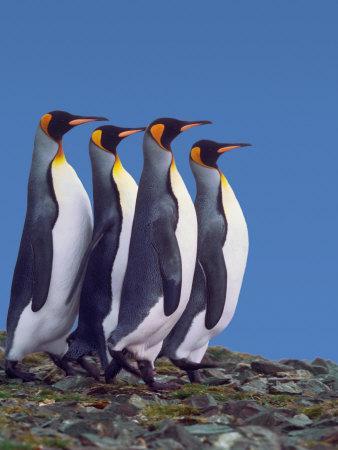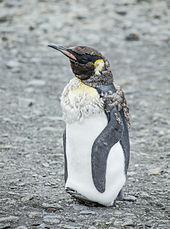The first image is the image on the left, the second image is the image on the right. For the images displayed, is the sentence "In total, there are no more than five penguins pictured." factually correct? Answer yes or no. Yes. 